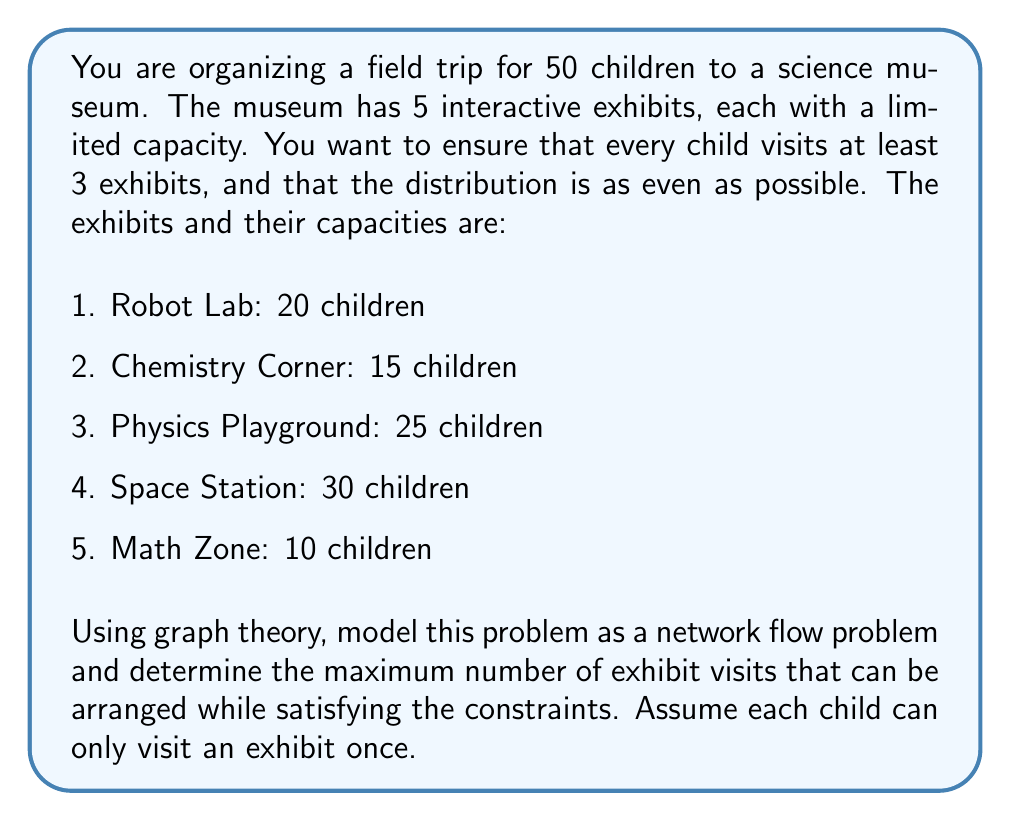Help me with this question. To solve this problem using graph theory, we can model it as a maximum flow problem:

1. Create a source node (S) representing the group of children.
2. Create a sink node (T) representing the total exhibit visits.
3. Create nodes for each exhibit (E1, E2, E3, E4, E5).
4. Create intermediate nodes (C1, C2, C3) representing the three visits each child must make.

The graph will look like this:

[asy]
import graph;

size(200);

void drawNode(pair p, string s) {
  fill(p, circle(p, 0.3), white);
  label(s, p);
}

drawNode((0,0), "S");
drawNode((2,2), "C1");
drawNode((2,0), "C2");
drawNode((2,-2), "C3");
drawNode((4,2), "E1");
drawNode((4,1), "E2");
drawNode((4,0), "E3");
drawNode((4,-1), "E4");
drawNode((4,-2), "E5");
drawNode((6,0), "T");

draw((0,0)--(2,2));
draw((0,0)--(2,0));
draw((0,0)--(2,-2));
draw((2,2)--(4,2));
draw((2,2)--(4,1));
draw((2,2)--(4,0));
draw((2,2)--(4,-1));
draw((2,2)--(4,-2));
draw((2,0)--(4,2));
draw((2,0)--(4,1));
draw((2,0)--(4,0));
draw((2,0)--(4,-1));
draw((2,0)--(4,-2));
draw((2,-2)--(4,2));
draw((2,-2)--(4,1));
draw((2,-2)--(4,0));
draw((2,-2)--(4,-1));
draw((2,-2)--(4,-2));
draw((4,2)--(6,0));
draw((4,1)--(6,0));
draw((4,0)--(6,0));
draw((4,-1)--(6,0));
draw((4,-2)--(6,0));
[/asy]

Now, let's assign capacities to the edges:

1. S to C1, C2, C3: 50 each (representing 50 children)
2. C1, C2, C3 to E1, E2, E3, E4, E5: infinite capacity
3. E1 to T: 20 (Robot Lab capacity)
4. E2 to T: 15 (Chemistry Corner capacity)
5. E3 to T: 25 (Physics Playground capacity)
6. E4 to T: 30 (Space Station capacity)
7. E5 to T: 10 (Math Zone capacity)

To solve this maximum flow problem, we can use the Ford-Fulkerson algorithm or any of its variants (e.g., Edmonds-Karp).

The maximum flow in this network will be the maximum number of exhibit visits that can be arranged.

Calculating the maximum flow:

1. The total capacity of the exhibits is 20 + 15 + 25 + 30 + 10 = 100 visits.
2. Each child must visit at least 3 exhibits, so the minimum number of visits is 50 * 3 = 150.
3. However, the exhibit capacities limit the total visits to 100.

Therefore, the maximum flow (maximum number of exhibit visits) is 100.

This means that not all children will be able to visit 3 exhibits, but this is the best distribution possible given the constraints.
Answer: The maximum number of exhibit visits that can be arranged is 100. 